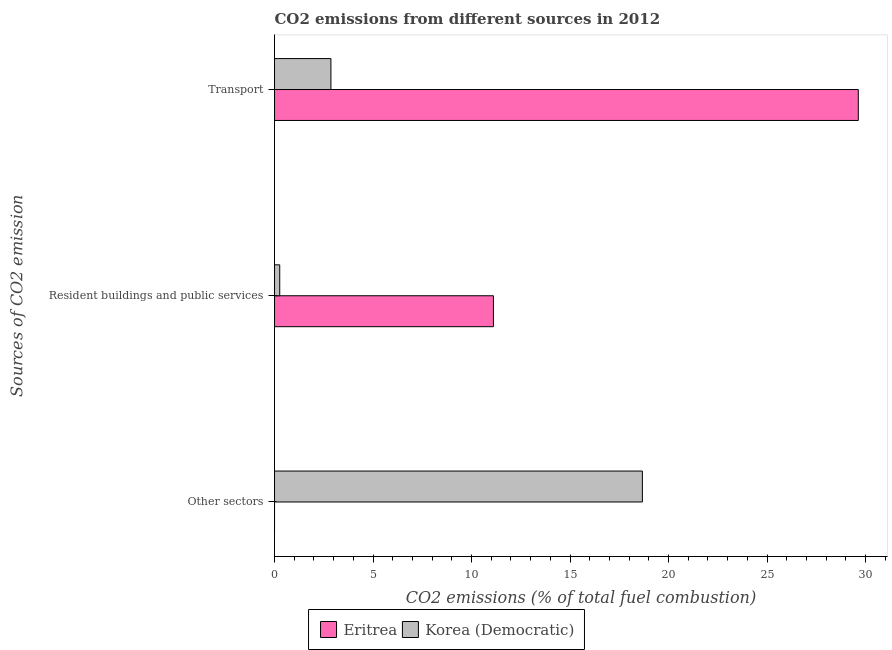How many different coloured bars are there?
Keep it short and to the point. 2. How many bars are there on the 3rd tick from the top?
Provide a succinct answer. 1. What is the label of the 2nd group of bars from the top?
Offer a very short reply. Resident buildings and public services. What is the percentage of co2 emissions from transport in Eritrea?
Your response must be concise. 29.63. Across all countries, what is the maximum percentage of co2 emissions from resident buildings and public services?
Make the answer very short. 11.11. Across all countries, what is the minimum percentage of co2 emissions from other sectors?
Make the answer very short. 0. In which country was the percentage of co2 emissions from other sectors maximum?
Offer a terse response. Korea (Democratic). What is the total percentage of co2 emissions from transport in the graph?
Offer a terse response. 32.49. What is the difference between the percentage of co2 emissions from resident buildings and public services in Eritrea and that in Korea (Democratic)?
Give a very brief answer. 10.85. What is the difference between the percentage of co2 emissions from other sectors in Eritrea and the percentage of co2 emissions from transport in Korea (Democratic)?
Provide a succinct answer. -2.86. What is the average percentage of co2 emissions from transport per country?
Your response must be concise. 16.25. What is the difference between the percentage of co2 emissions from resident buildings and public services and percentage of co2 emissions from other sectors in Korea (Democratic)?
Ensure brevity in your answer.  -18.41. In how many countries, is the percentage of co2 emissions from resident buildings and public services greater than 16 %?
Keep it short and to the point. 0. What is the ratio of the percentage of co2 emissions from transport in Korea (Democratic) to that in Eritrea?
Your answer should be compact. 0.1. What is the difference between the highest and the second highest percentage of co2 emissions from resident buildings and public services?
Keep it short and to the point. 10.85. What is the difference between the highest and the lowest percentage of co2 emissions from resident buildings and public services?
Give a very brief answer. 10.85. How many bars are there?
Provide a succinct answer. 5. Are all the bars in the graph horizontal?
Offer a terse response. Yes. How many countries are there in the graph?
Give a very brief answer. 2. What is the difference between two consecutive major ticks on the X-axis?
Give a very brief answer. 5. Does the graph contain any zero values?
Offer a very short reply. Yes. Does the graph contain grids?
Provide a succinct answer. No. Where does the legend appear in the graph?
Your answer should be very brief. Bottom center. How many legend labels are there?
Give a very brief answer. 2. How are the legend labels stacked?
Keep it short and to the point. Horizontal. What is the title of the graph?
Your response must be concise. CO2 emissions from different sources in 2012. What is the label or title of the X-axis?
Your answer should be very brief. CO2 emissions (% of total fuel combustion). What is the label or title of the Y-axis?
Provide a succinct answer. Sources of CO2 emission. What is the CO2 emissions (% of total fuel combustion) of Korea (Democratic) in Other sectors?
Provide a succinct answer. 18.67. What is the CO2 emissions (% of total fuel combustion) of Eritrea in Resident buildings and public services?
Your response must be concise. 11.11. What is the CO2 emissions (% of total fuel combustion) of Korea (Democratic) in Resident buildings and public services?
Offer a very short reply. 0.26. What is the CO2 emissions (% of total fuel combustion) in Eritrea in Transport?
Your response must be concise. 29.63. What is the CO2 emissions (% of total fuel combustion) of Korea (Democratic) in Transport?
Offer a terse response. 2.86. Across all Sources of CO2 emission, what is the maximum CO2 emissions (% of total fuel combustion) in Eritrea?
Provide a short and direct response. 29.63. Across all Sources of CO2 emission, what is the maximum CO2 emissions (% of total fuel combustion) of Korea (Democratic)?
Provide a short and direct response. 18.67. Across all Sources of CO2 emission, what is the minimum CO2 emissions (% of total fuel combustion) in Eritrea?
Ensure brevity in your answer.  0. Across all Sources of CO2 emission, what is the minimum CO2 emissions (% of total fuel combustion) in Korea (Democratic)?
Make the answer very short. 0.26. What is the total CO2 emissions (% of total fuel combustion) in Eritrea in the graph?
Keep it short and to the point. 40.74. What is the total CO2 emissions (% of total fuel combustion) in Korea (Democratic) in the graph?
Your answer should be compact. 21.8. What is the difference between the CO2 emissions (% of total fuel combustion) in Korea (Democratic) in Other sectors and that in Resident buildings and public services?
Your answer should be compact. 18.41. What is the difference between the CO2 emissions (% of total fuel combustion) in Korea (Democratic) in Other sectors and that in Transport?
Your answer should be very brief. 15.81. What is the difference between the CO2 emissions (% of total fuel combustion) of Eritrea in Resident buildings and public services and that in Transport?
Give a very brief answer. -18.52. What is the difference between the CO2 emissions (% of total fuel combustion) of Korea (Democratic) in Resident buildings and public services and that in Transport?
Your response must be concise. -2.6. What is the difference between the CO2 emissions (% of total fuel combustion) of Eritrea in Resident buildings and public services and the CO2 emissions (% of total fuel combustion) of Korea (Democratic) in Transport?
Keep it short and to the point. 8.25. What is the average CO2 emissions (% of total fuel combustion) in Eritrea per Sources of CO2 emission?
Ensure brevity in your answer.  13.58. What is the average CO2 emissions (% of total fuel combustion) in Korea (Democratic) per Sources of CO2 emission?
Your answer should be compact. 7.27. What is the difference between the CO2 emissions (% of total fuel combustion) in Eritrea and CO2 emissions (% of total fuel combustion) in Korea (Democratic) in Resident buildings and public services?
Provide a succinct answer. 10.85. What is the difference between the CO2 emissions (% of total fuel combustion) in Eritrea and CO2 emissions (% of total fuel combustion) in Korea (Democratic) in Transport?
Provide a succinct answer. 26.77. What is the ratio of the CO2 emissions (% of total fuel combustion) in Korea (Democratic) in Other sectors to that in Resident buildings and public services?
Provide a short and direct response. 70.67. What is the ratio of the CO2 emissions (% of total fuel combustion) of Korea (Democratic) in Other sectors to that in Transport?
Your answer should be very brief. 6.52. What is the ratio of the CO2 emissions (% of total fuel combustion) in Korea (Democratic) in Resident buildings and public services to that in Transport?
Offer a terse response. 0.09. What is the difference between the highest and the second highest CO2 emissions (% of total fuel combustion) of Korea (Democratic)?
Provide a succinct answer. 15.81. What is the difference between the highest and the lowest CO2 emissions (% of total fuel combustion) of Eritrea?
Give a very brief answer. 29.63. What is the difference between the highest and the lowest CO2 emissions (% of total fuel combustion) of Korea (Democratic)?
Your answer should be very brief. 18.41. 